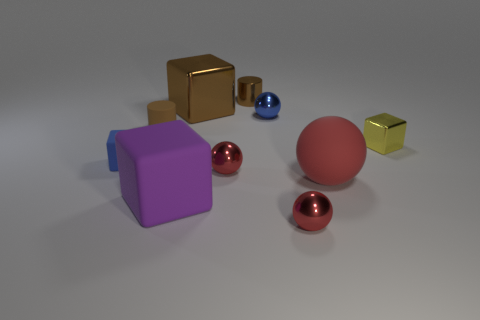Subtract all yellow cylinders. How many red spheres are left? 3 Subtract all red cubes. Subtract all brown cylinders. How many cubes are left? 4 Subtract all spheres. How many objects are left? 6 Add 6 red metallic things. How many red metallic things are left? 8 Add 7 large purple blocks. How many large purple blocks exist? 8 Subtract 0 blue cylinders. How many objects are left? 10 Subtract all small green metallic cylinders. Subtract all small matte cylinders. How many objects are left? 9 